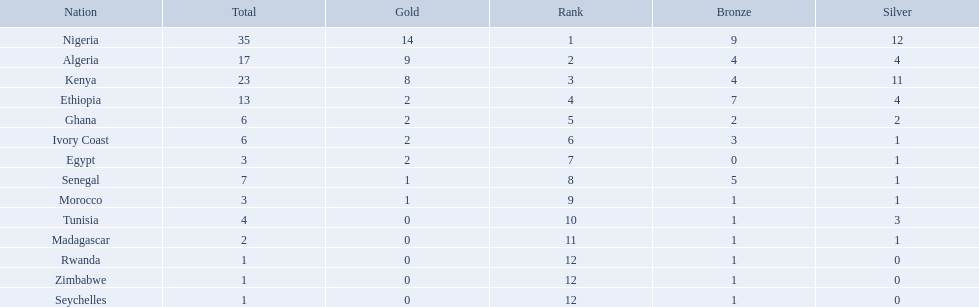Which nations competed in the 1989 african championships in athletics? Nigeria, Algeria, Kenya, Ethiopia, Ghana, Ivory Coast, Egypt, Senegal, Morocco, Tunisia, Madagascar, Rwanda, Zimbabwe, Seychelles. Of these nations, which earned 0 bronze medals? Egypt. 